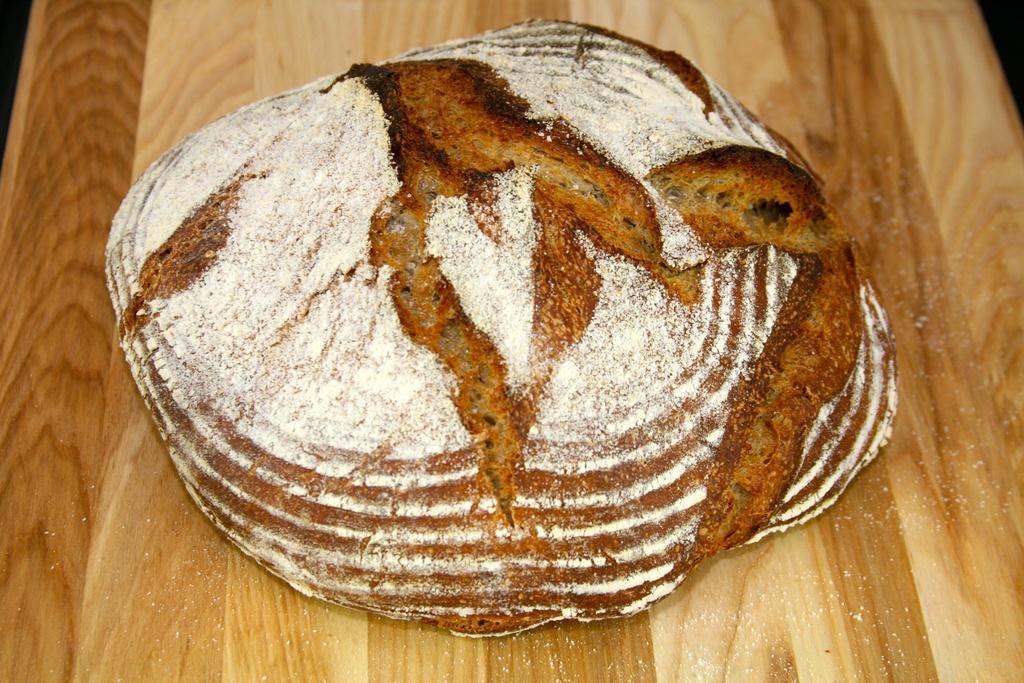Can you describe this image briefly? On this wooden surface we can see a food. 